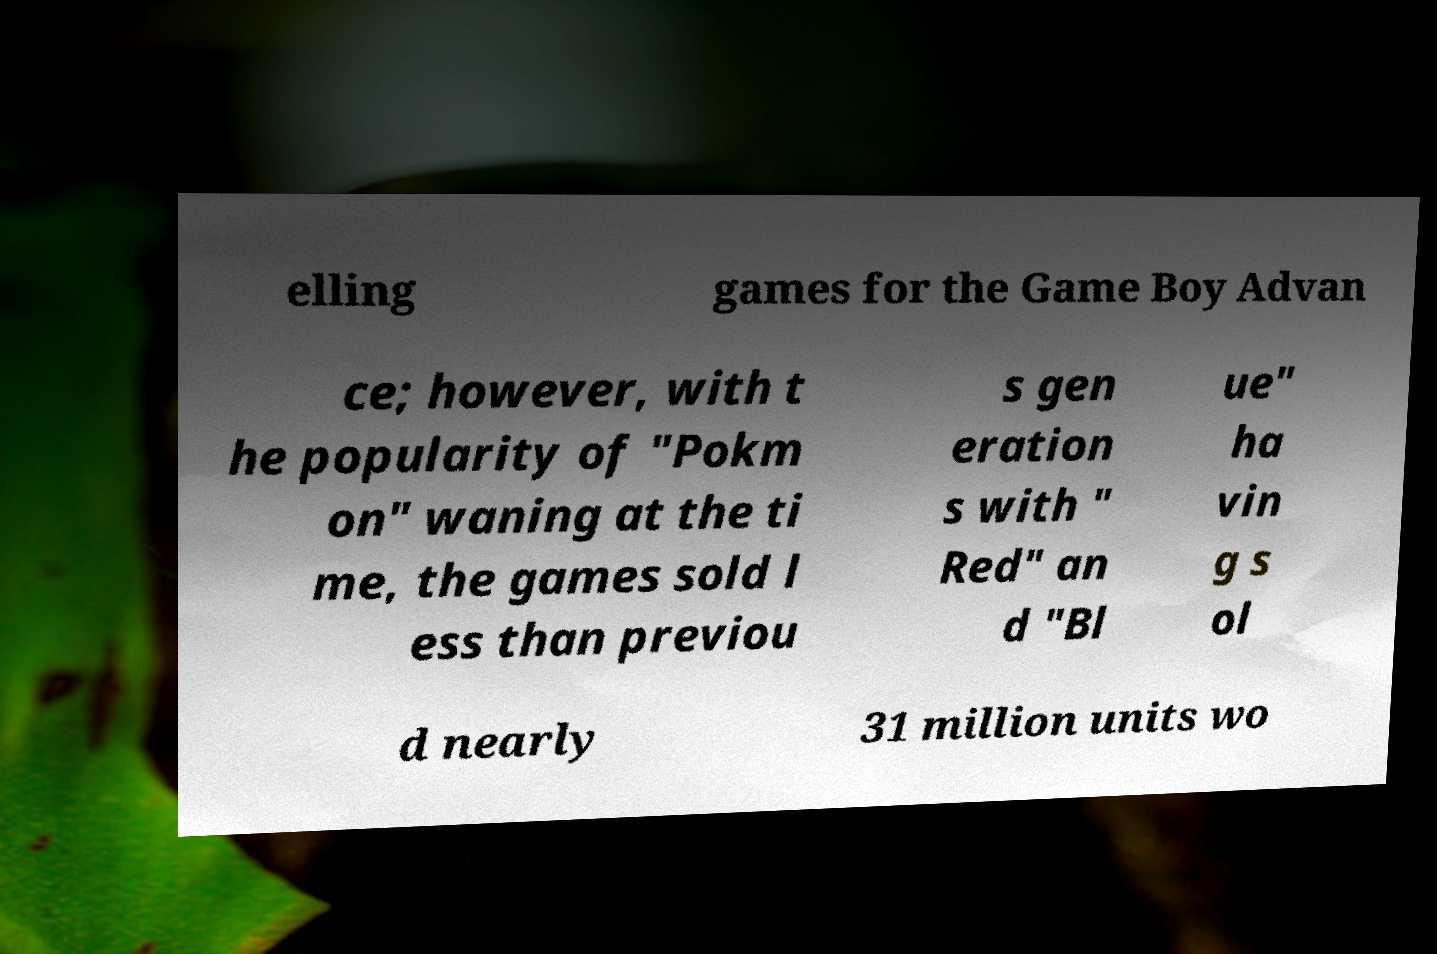There's text embedded in this image that I need extracted. Can you transcribe it verbatim? elling games for the Game Boy Advan ce; however, with t he popularity of "Pokm on" waning at the ti me, the games sold l ess than previou s gen eration s with " Red" an d "Bl ue" ha vin g s ol d nearly 31 million units wo 